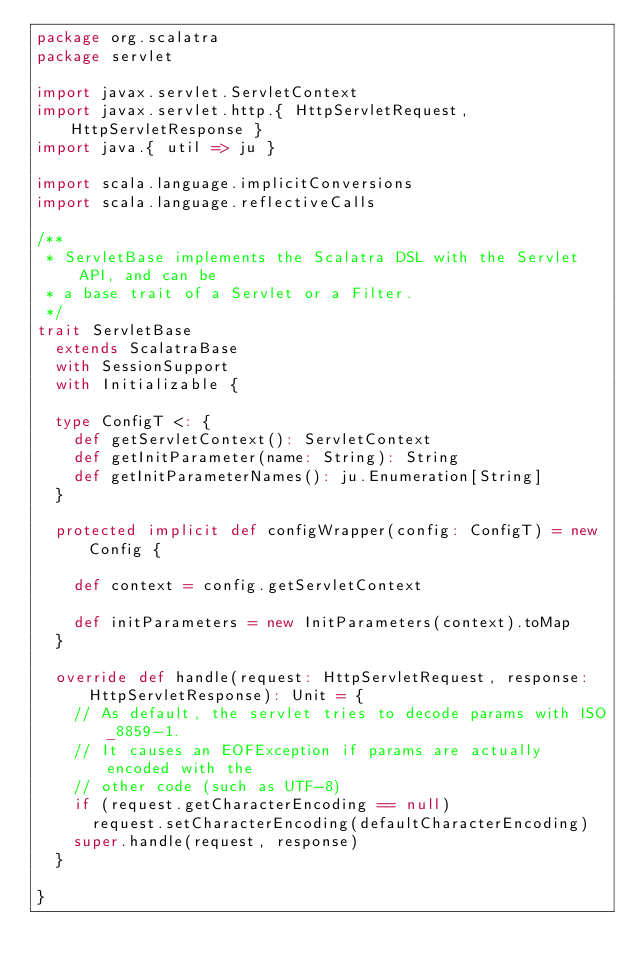Convert code to text. <code><loc_0><loc_0><loc_500><loc_500><_Scala_>package org.scalatra
package servlet

import javax.servlet.ServletContext
import javax.servlet.http.{ HttpServletRequest, HttpServletResponse }
import java.{ util => ju }

import scala.language.implicitConversions
import scala.language.reflectiveCalls

/**
 * ServletBase implements the Scalatra DSL with the Servlet API, and can be
 * a base trait of a Servlet or a Filter.
 */
trait ServletBase
  extends ScalatraBase
  with SessionSupport
  with Initializable {

  type ConfigT <: {
    def getServletContext(): ServletContext
    def getInitParameter(name: String): String
    def getInitParameterNames(): ju.Enumeration[String]
  }

  protected implicit def configWrapper(config: ConfigT) = new Config {

    def context = config.getServletContext

    def initParameters = new InitParameters(context).toMap
  }

  override def handle(request: HttpServletRequest, response: HttpServletResponse): Unit = {
    // As default, the servlet tries to decode params with ISO_8859-1.
    // It causes an EOFException if params are actually encoded with the
    // other code (such as UTF-8)
    if (request.getCharacterEncoding == null)
      request.setCharacterEncoding(defaultCharacterEncoding)
    super.handle(request, response)
  }

}
</code> 